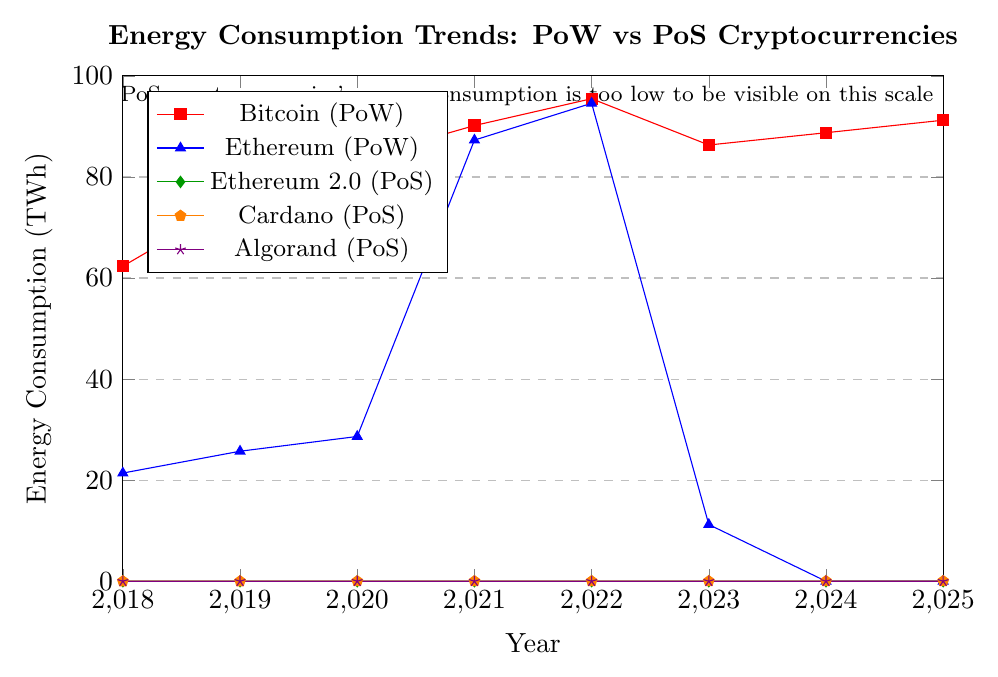What is the overall trend in energy consumption for Bitcoin (PoW) from 2018 to 2025? To determine the trend, observe the data points for Bitcoin (PoW) from 2018 (62.34 TWh) to 2025 (91.23 TWh). The data shows a general increasing trend over the years, with a peak in 2022 (95.48 TWh) and slight fluctuations in 2023 and 2024.
Answer: Increasing trend Which cryptocurrency shows the highest energy consumption in 2022? Compare the energy consumptions of Bitcoin (PoW), Ethereum (PoW), Ethereum 2.0 (PoS), Cardano (PoS), and Algorand (PoS) in 2022. Bitcoin (PoW) is at 95.48 TWh and Ethereum (PoW) is at 94.58 TWh. The others are significantly lower. Thus, Bitcoin (PoW) has the highest energy consumption in 2022.
Answer: Bitcoin (PoW) How does Ethereum's (PoW) energy consumption change from 2021 to 2023? Observe the Ethereum (PoW) data points: 87.29 TWh in 2021, 94.58 TWh in 2022, and 11.22 TWh in 2023. Energy consumption peaks sharply in 2022 and drops drastically in 2023.
Answer: Peaks in 2022, then drops How much greater is Bitcoin's (PoW) energy consumption in 2021 compared to Ethereum (PoW)? Bitcoin (PoW) in 2021 is 90.17 TWh, while Ethereum (PoW) in 2021 is 87.29 TWh. The difference is 90.17 - 87.29 = 2.88 TWh.
Answer: 2.88 TWh What is the percentage decrease in Ethereum 2.0 (PoS) energy consumption from 2022 to 2023? Calculate the percentage decrease using the formula: \[(\frac{0.0136 - 0.0082}{0.0136}) \times 100\% = 39.71\%\]
Answer: 39.71% Between Cardano (PoS) and Algorand (PoS), which has shown a steeper overall increase in energy consumption from 2018 to 2025? Cardano (PoS) rises from 0.006 TWh to 0.033 TWh, an increase of 0.027 TWh. Algorand (PoS) rises from 0.0001 TWh to 0.0019 TWh, an increase of 0.0018 TWh. Cardano (PoS) shows a steeper increase.
Answer: Cardano (PoS) What can you infer about the energy consumption of proof-of-stake (PoS) cryptocurrencies compared to proof-of-work (PoW) cryptocurrencies from this chart? Visually, PoS cryptocurrencies (Ethereum 2.0, Cardano, Algorand) have consistently much lower energy consumption compared to PoW cryptocurrencies (Bitcoin, Ethereum), indicated by significantly lower y-axis values.
Answer: PoS consumes much less energy Which proof-of-stake cryptocurrency has the highest energy consumption in 2025? Compare Cardano (PoS) at 0.033 TWh, Algorand (PoS) at 0.0019 TWh, and Ethereum 2.0 (PoS) at 0.0054 TWh in 2025. Cardano (PoS) has the highest energy consumption among them.
Answer: Cardano (PoS) In which year did Ethereum (PoW) experience the sharpest increase in energy consumption? Observe the drastic jump from 28.65 TWh in 2020 to 87.29 TWh in 2021, which is the sharpest increase in Ethereum (PoW) energy consumption.
Answer: 2021 What is the average energy consumption of Cardano (PoS) from 2018 to 2025? Calculate the average: \[(\frac{0.006 + 0.008 + 0.01 + 0.014 + 0.019 + 0.023 + 0.028 + 0.033}{8}) = 0.01775\] TWh
Answer: 0.01775 TWh 